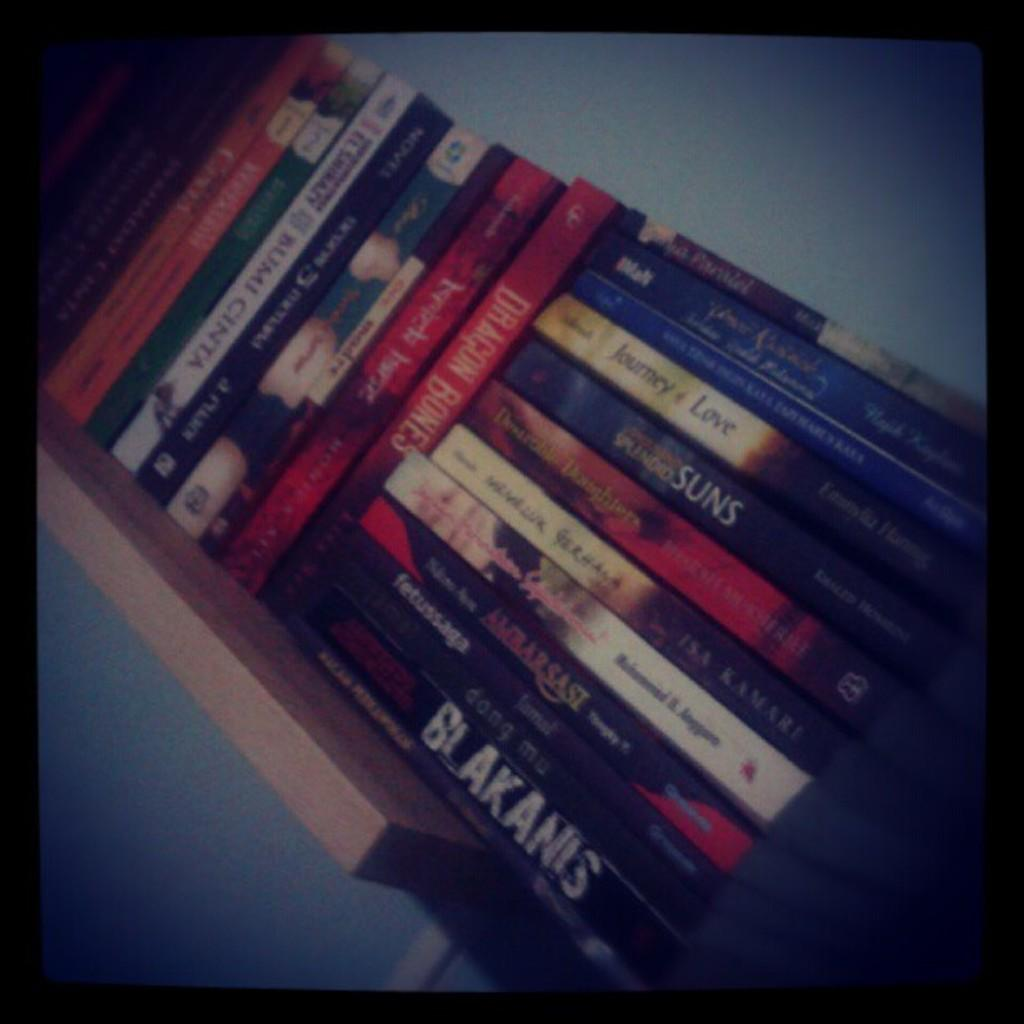<image>
Write a terse but informative summary of the picture. A shelf with various books with one titled Suns. 